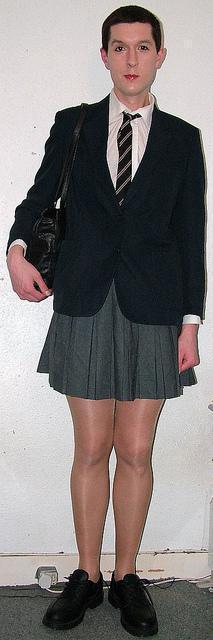What kind of uniform is worn by the man in this picture?
Select the accurate response from the four choices given to answer the question.
Options: Police, school, cheerleader, football. School. 